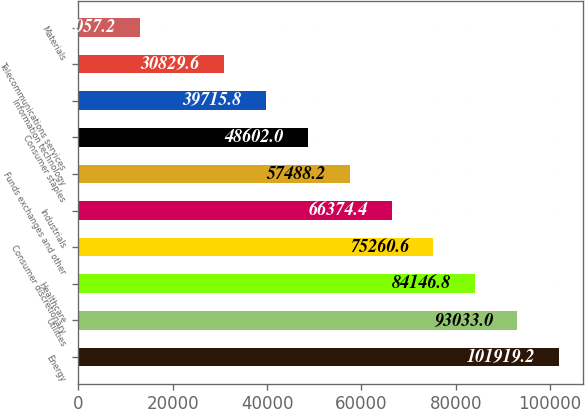Convert chart to OTSL. <chart><loc_0><loc_0><loc_500><loc_500><bar_chart><fcel>Energy<fcel>Utilities<fcel>Healthcare<fcel>Consumer discretionary<fcel>Industrials<fcel>Funds exchanges and other<fcel>Consumer staples<fcel>Information technology<fcel>Telecommunications services<fcel>Materials<nl><fcel>101919<fcel>93033<fcel>84146.8<fcel>75260.6<fcel>66374.4<fcel>57488.2<fcel>48602<fcel>39715.8<fcel>30829.6<fcel>13057.2<nl></chart> 